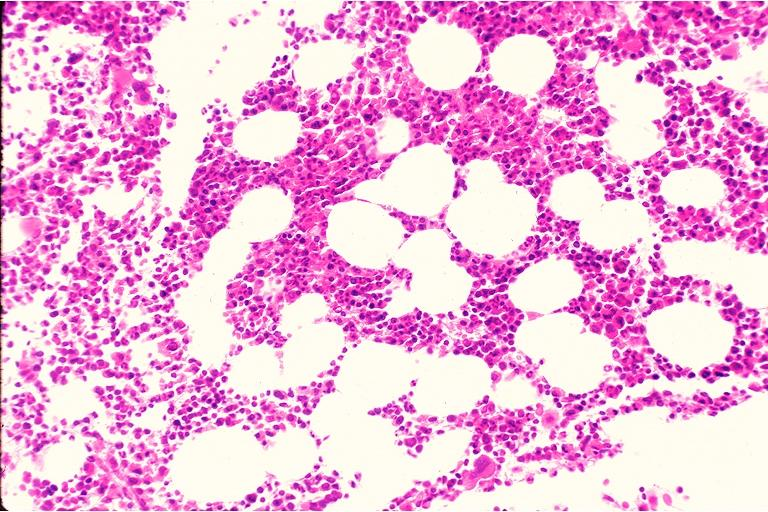what is present?
Answer the question using a single word or phrase. Oral 